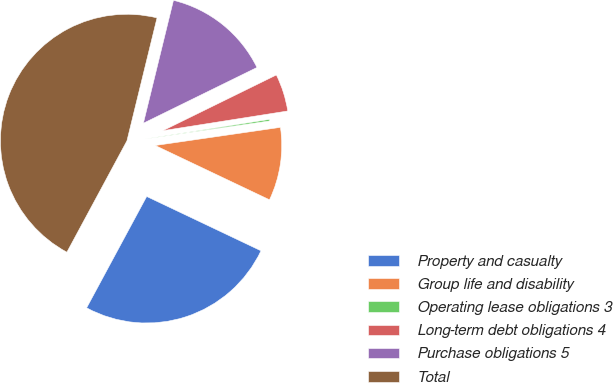Convert chart to OTSL. <chart><loc_0><loc_0><loc_500><loc_500><pie_chart><fcel>Property and casualty<fcel>Group life and disability<fcel>Operating lease obligations 3<fcel>Long-term debt obligations 4<fcel>Purchase obligations 5<fcel>Total<nl><fcel>25.81%<fcel>9.35%<fcel>0.2%<fcel>4.77%<fcel>13.92%<fcel>45.95%<nl></chart> 